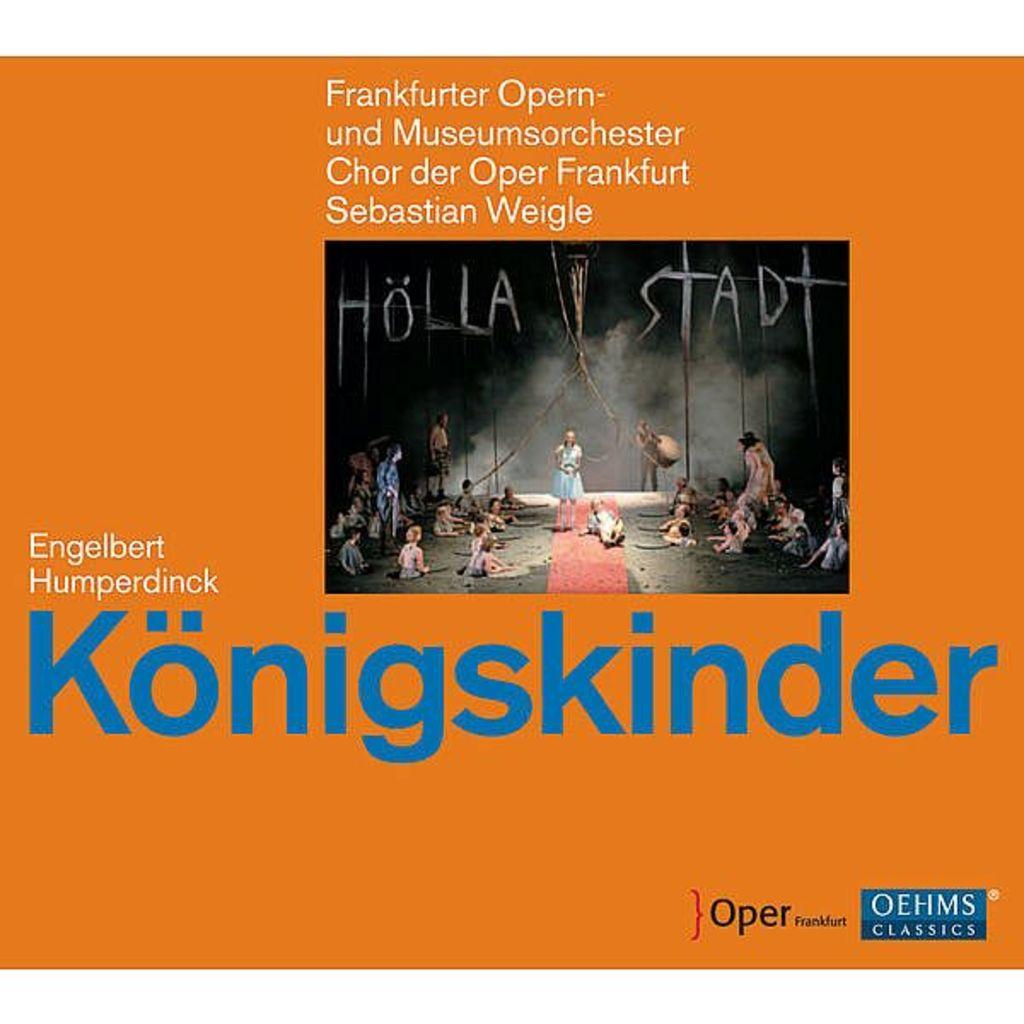Provide a one-sentence caption for the provided image. An orange cover is displayed with Konigskinder in large blue print. 